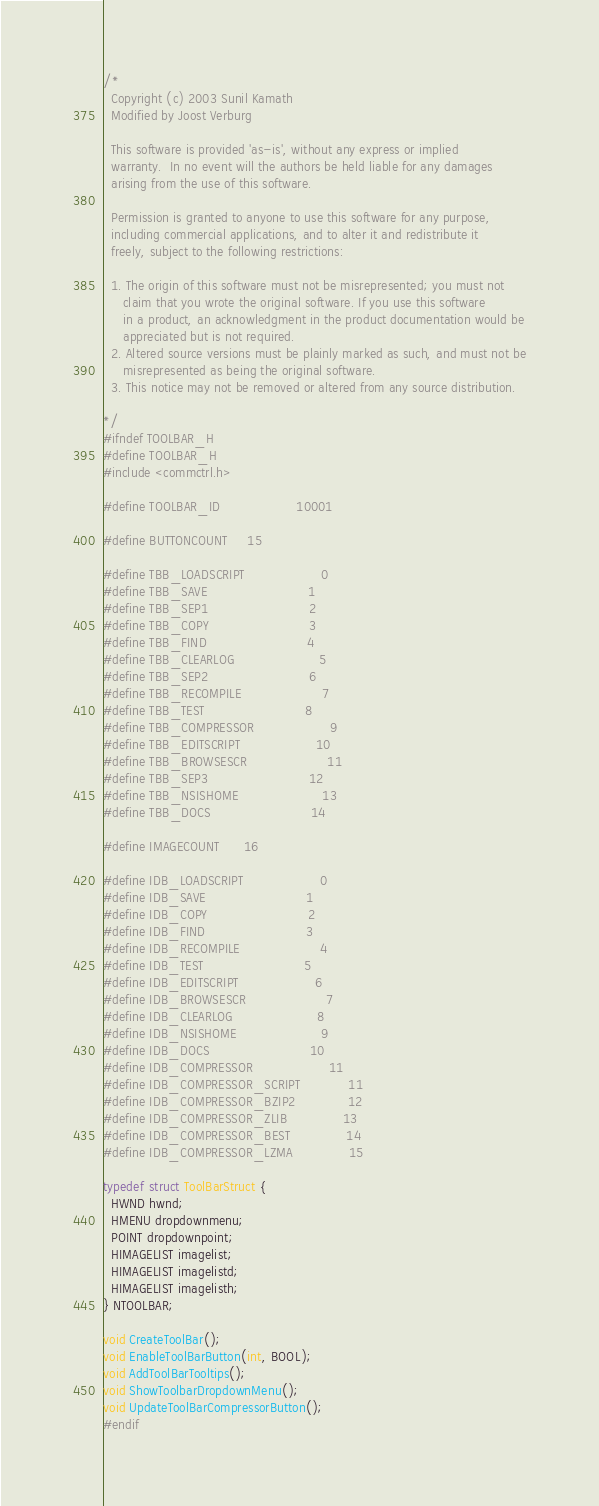Convert code to text. <code><loc_0><loc_0><loc_500><loc_500><_C_>/*
  Copyright (c) 2003 Sunil Kamath
  Modified by Joost Verburg

  This software is provided 'as-is', without any express or implied
  warranty.  In no event will the authors be held liable for any damages
  arising from the use of this software.

  Permission is granted to anyone to use this software for any purpose,
  including commercial applications, and to alter it and redistribute it
  freely, subject to the following restrictions:

  1. The origin of this software must not be misrepresented; you must not
     claim that you wrote the original software. If you use this software
     in a product, an acknowledgment in the product documentation would be
     appreciated but is not required.
  2. Altered source versions must be plainly marked as such, and must not be
     misrepresented as being the original software.
  3. This notice may not be removed or altered from any source distribution.

*/
#ifndef TOOLBAR_H
#define TOOLBAR_H
#include <commctrl.h>

#define TOOLBAR_ID                   10001

#define BUTTONCOUNT     15

#define TBB_LOADSCRIPT                   0
#define TBB_SAVE                         1
#define TBB_SEP1                         2
#define TBB_COPY                         3
#define TBB_FIND                         4
#define TBB_CLEARLOG                     5
#define TBB_SEP2                         6
#define TBB_RECOMPILE                    7
#define TBB_TEST                         8
#define TBB_COMPRESSOR                   9
#define TBB_EDITSCRIPT                   10
#define TBB_BROWSESCR                    11
#define TBB_SEP3                         12
#define TBB_NSISHOME                     13
#define TBB_DOCS                         14

#define IMAGECOUNT      16

#define IDB_LOADSCRIPT                   0
#define IDB_SAVE                         1
#define IDB_COPY                         2
#define IDB_FIND                         3
#define IDB_RECOMPILE                    4
#define IDB_TEST                         5
#define IDB_EDITSCRIPT                   6
#define IDB_BROWSESCR                    7
#define IDB_CLEARLOG                     8
#define IDB_NSISHOME                     9
#define IDB_DOCS                         10
#define IDB_COMPRESSOR                   11
#define IDB_COMPRESSOR_SCRIPT            11
#define IDB_COMPRESSOR_BZIP2             12
#define IDB_COMPRESSOR_ZLIB              13
#define IDB_COMPRESSOR_BEST              14
#define IDB_COMPRESSOR_LZMA              15

typedef struct ToolBarStruct {
  HWND hwnd;
  HMENU dropdownmenu;
  POINT dropdownpoint;
  HIMAGELIST imagelist;
  HIMAGELIST imagelistd;
  HIMAGELIST imagelisth;
} NTOOLBAR;

void CreateToolBar();
void EnableToolBarButton(int, BOOL);
void AddToolBarTooltips();
void ShowToolbarDropdownMenu();
void UpdateToolBarCompressorButton();
#endif</code> 